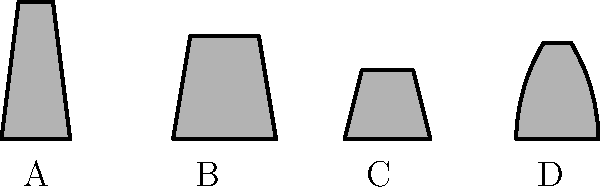Which silhouette represents the traditional Weizen (wheat beer) glass, known for its tall and slightly curved shape? To identify the Weizen glass, let's analyze each silhouette:

1. Glass A: This is a tall, slender glass with a slight inward taper at the top. This shape is characteristic of a Pilsner glass, typically used for lighter lagers.

2. Glass B: This glass has a wide base that narrows towards the top, creating a curved profile. It's the tallest of the four glasses and has the distinctive shape of a Weizen glass, designed to showcase the aromatic and visual qualities of wheat beers.

3. Glass C: This is a short, straight-sided glass with a slight taper. This shape is typical of a Stange glass, traditionally used for Kölsch beer.

4. Glass D: This glass has a bulbous body that narrows at the top, resembling a tulip shape. This is likely a Tulip glass, often used for stronger or more aromatic beers.

Given these characteristics, the glass that best represents the traditional Weizen glass is silhouette B. It has the tall, slightly curved shape that is iconic for serving wheat beers, allowing room for the fluffy head and capturing the beer's aroma.
Answer: B 